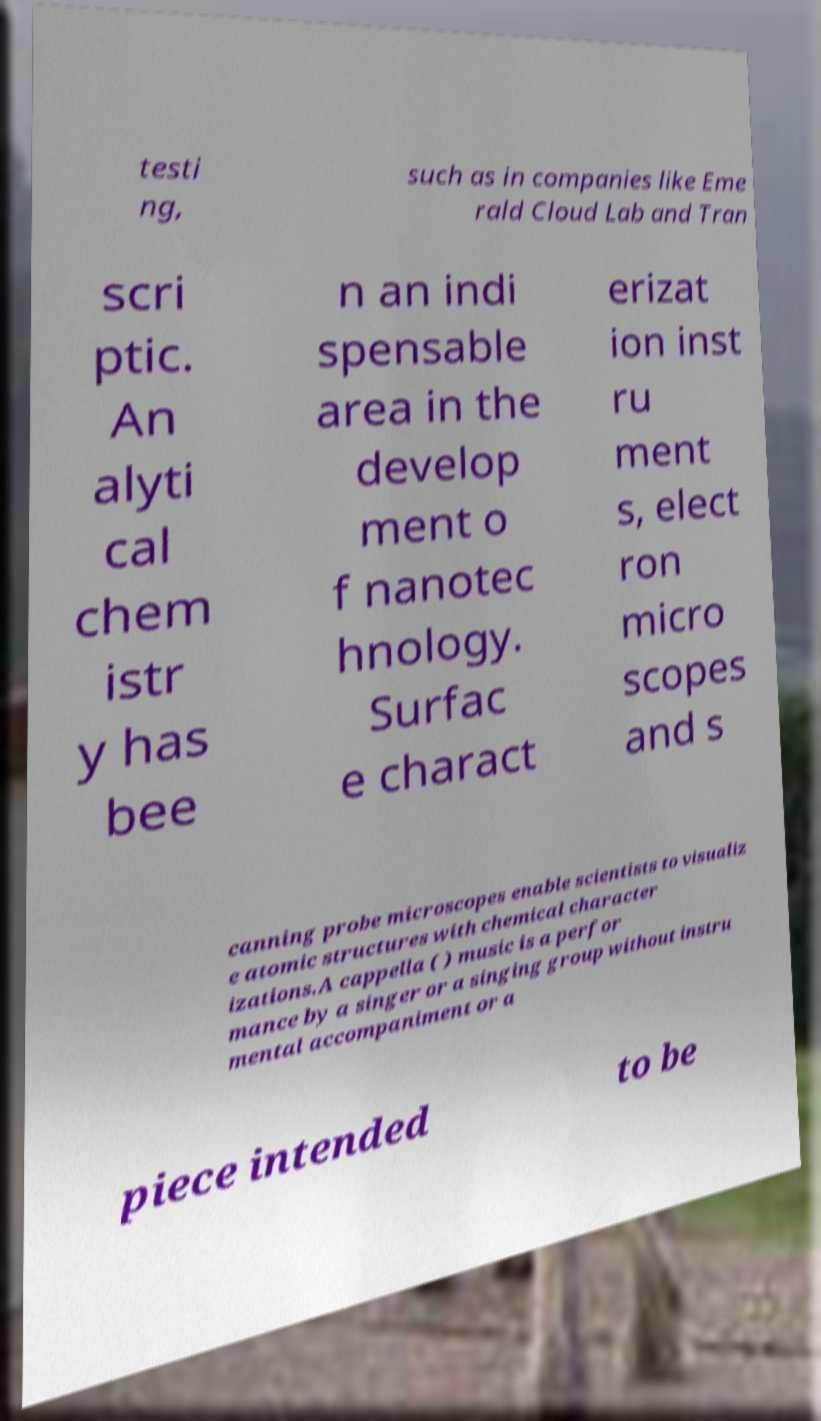I need the written content from this picture converted into text. Can you do that? testi ng, such as in companies like Eme rald Cloud Lab and Tran scri ptic. An alyti cal chem istr y has bee n an indi spensable area in the develop ment o f nanotec hnology. Surfac e charact erizat ion inst ru ment s, elect ron micro scopes and s canning probe microscopes enable scientists to visualiz e atomic structures with chemical character izations.A cappella ( ) music is a perfor mance by a singer or a singing group without instru mental accompaniment or a piece intended to be 